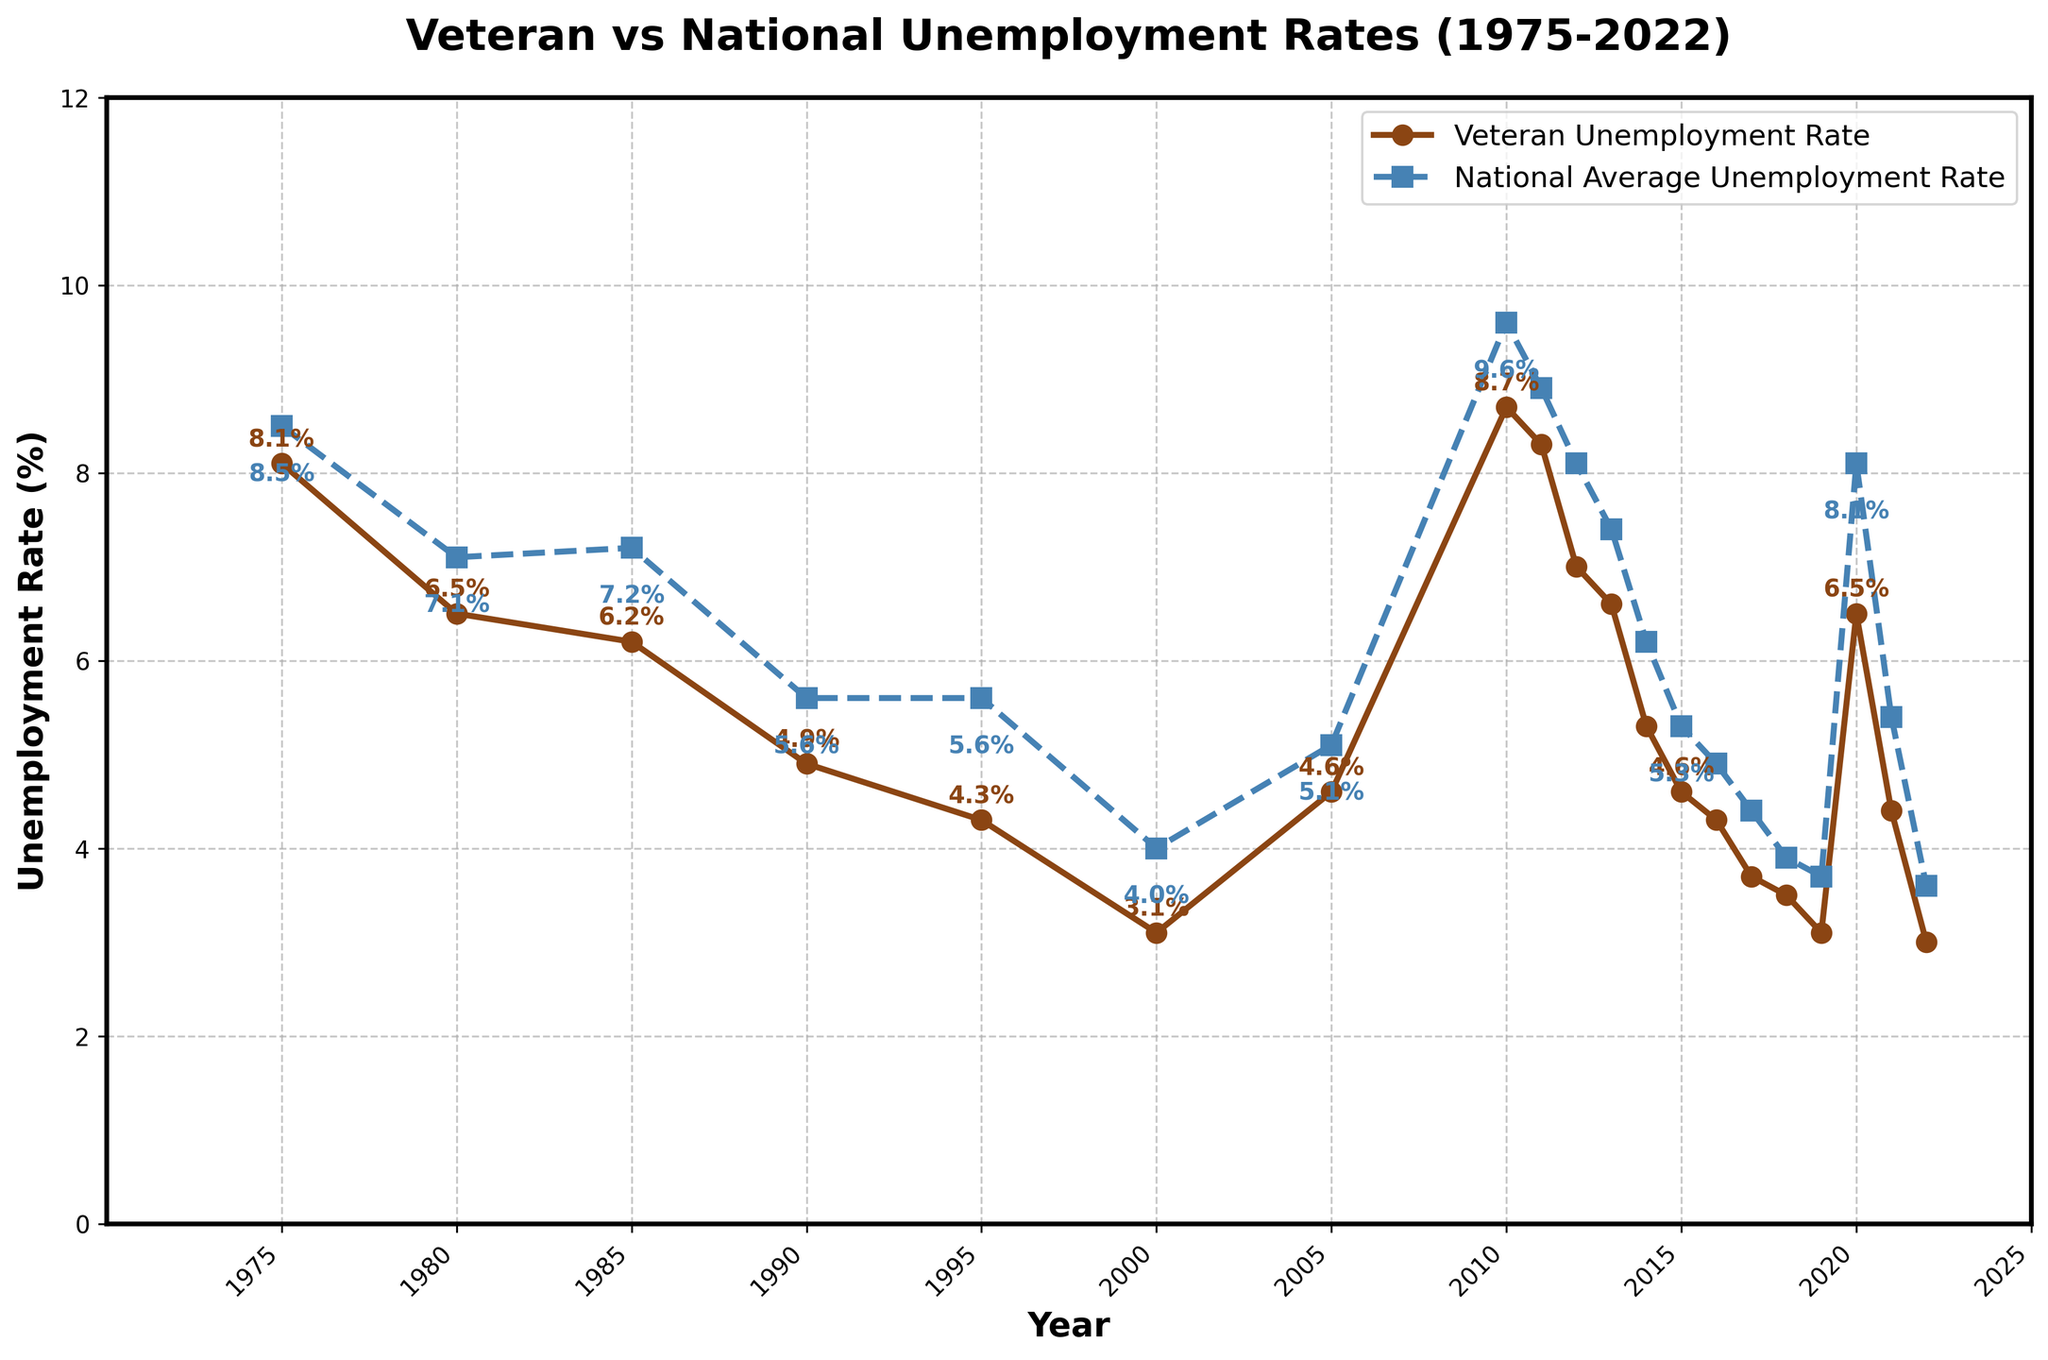What was the unemployment rate for veterans in 1975? Locate the point corresponding to the year 1975 on the 'Veteran Unemployment Rate' line and read the value.
Answer: 8.1% Which year had the highest national average unemployment rate and what was it? Identify the peak of the 'National Average Unemployment Rate' line and note the corresponding year and rate.
Answer: 2010, 9.6% How does the veteran unemployment rate in 2020 compare to the national average unemployment rate in the same year? Locate the rates for the year 2020 on both lines and compare them.
Answer: Veteran: 6.5%, National: 8.1% What is the percentage difference between the veteran and national average unemployment rates in 1985? Calculate the difference between the 'Veteran Unemployment Rate' and 'National Average Unemployment Rate' for 1985. Difference = National - Veteran = 7.2% - 6.2% = 1.0%
Answer: 1.0% In which years did the veteran unemployment rate equal the national average unemployment rate? Look for years where both lines intersect at the same unemployment rate level. There are no intersections in the provided timeline.
Answer: None Between which consecutive years was there the largest decrease in veteran unemployment rate? Calculate the difference in the 'Veteran Unemployment Rate' between consecutive years and identify the pair with the largest decrease.
Answer: 2010 to 2011, 8.7% to 8.3%, Decrease = 0.4% Which year had the lowest veteran unemployment rate and what was it? Identify the lowest point on the 'Veteran Unemployment Rate' line and note the corresponding year and rate.
Answer: 2022, 3.0% During the 2000-2010 period, was there any year when the veteran unemployment rate was higher than the national average unemployment rate? Review the 'Veteran Unemployment Rate' and 'National Average Unemployment Rate' values from 2000 to 2010 and see if the veteran rate exceeds the national rate in any year.
Answer: No How did the veteran unemployment rate change from 1975 to 2022? Find the veteran unemployment rates for 1975 and 2022, then calculate the difference. Change = Rate in 1975 - Rate in 2022 = 8.1% - 3.0% = 5.1% decrease
Answer: 5.1% decrease 